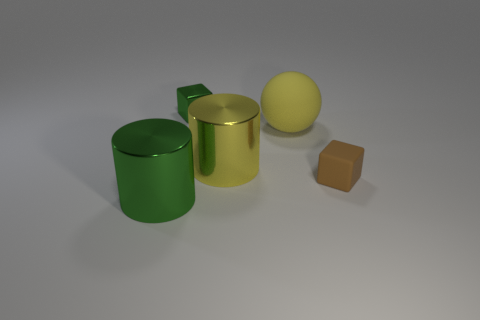Add 4 purple cubes. How many objects exist? 9 Subtract all cylinders. How many objects are left? 3 Subtract all small blue rubber balls. Subtract all green cubes. How many objects are left? 4 Add 4 brown matte cubes. How many brown matte cubes are left? 5 Add 5 yellow metallic cylinders. How many yellow metallic cylinders exist? 6 Subtract 0 green balls. How many objects are left? 5 